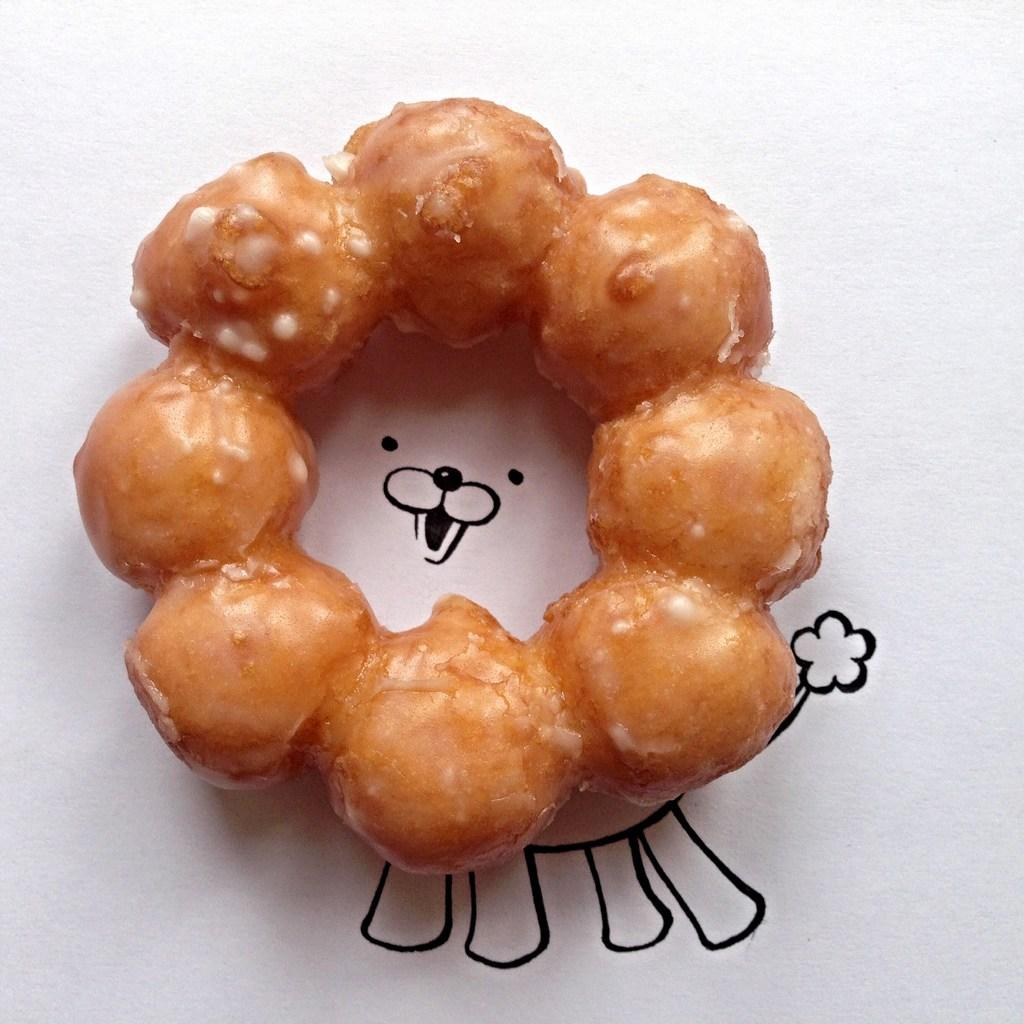What type of food is visible in the image? There are sweet balls in the image. What else can be seen under the sweet balls? There is a drawing under the sweet balls. What toy is being used to catch the wind in the image? There is no toy or wind present in the image. 